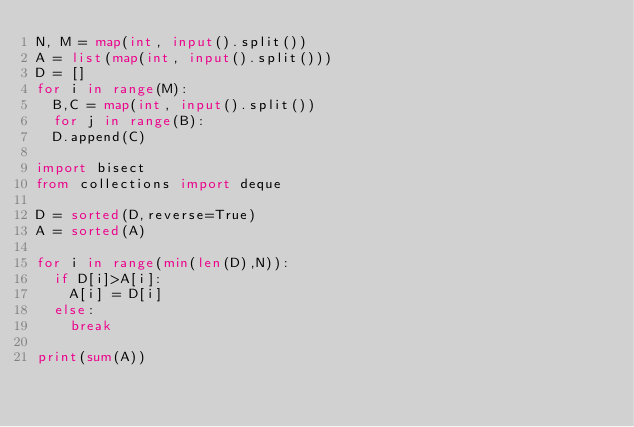<code> <loc_0><loc_0><loc_500><loc_500><_Python_>N, M = map(int, input().split())
A = list(map(int, input().split()))
D = []
for i in range(M):
  B,C = map(int, input().split())
  for j in range(B):
  D.append(C)

import bisect
from collections import deque

D = sorted(D,reverse=True)
A = sorted(A)

for i in range(min(len(D),N)):
  if D[i]>A[i]:
    A[i] = D[i]
  else:
    break
    
print(sum(A))
</code> 